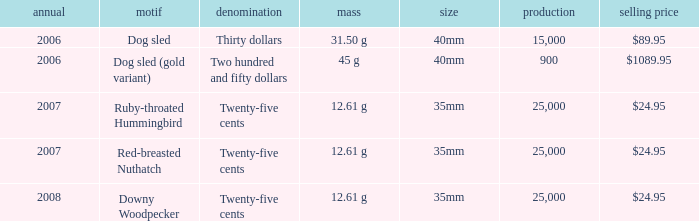What is the Theme of the coin with an Issue Price of $89.95? Dog sled. 